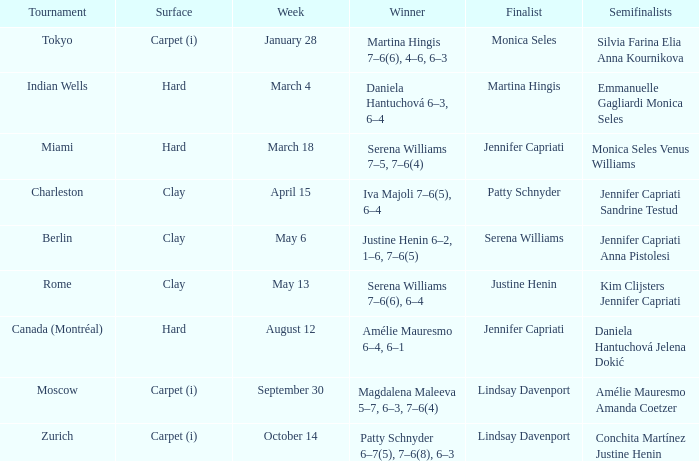In which week was the finalist martina hingis? March 4. 